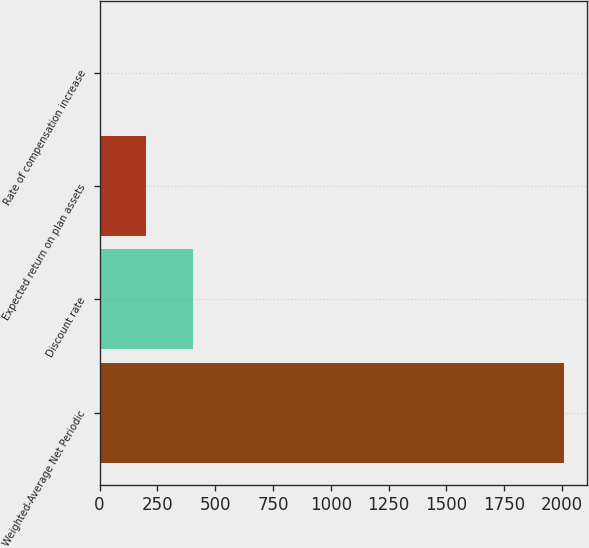Convert chart. <chart><loc_0><loc_0><loc_500><loc_500><bar_chart><fcel>Weighted-Average Net Periodic<fcel>Discount rate<fcel>Expected return on plan assets<fcel>Rate of compensation increase<nl><fcel>2007<fcel>402.63<fcel>202.08<fcel>1.53<nl></chart> 